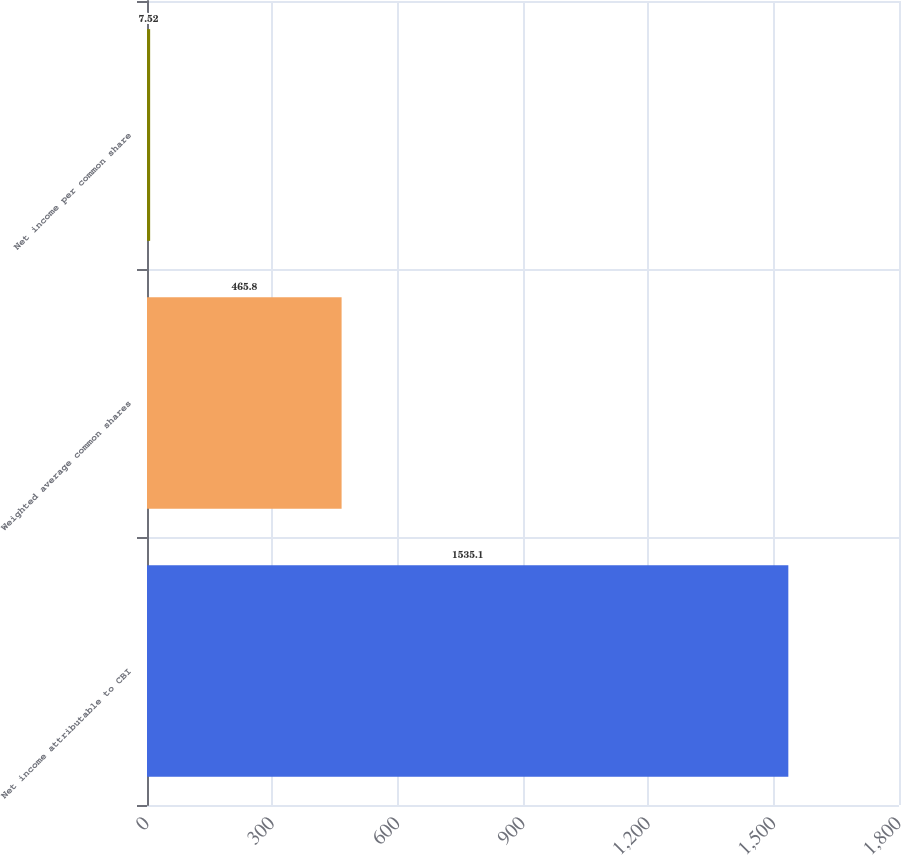Convert chart. <chart><loc_0><loc_0><loc_500><loc_500><bar_chart><fcel>Net income attributable to CBI<fcel>Weighted average common shares<fcel>Net income per common share<nl><fcel>1535.1<fcel>465.8<fcel>7.52<nl></chart> 